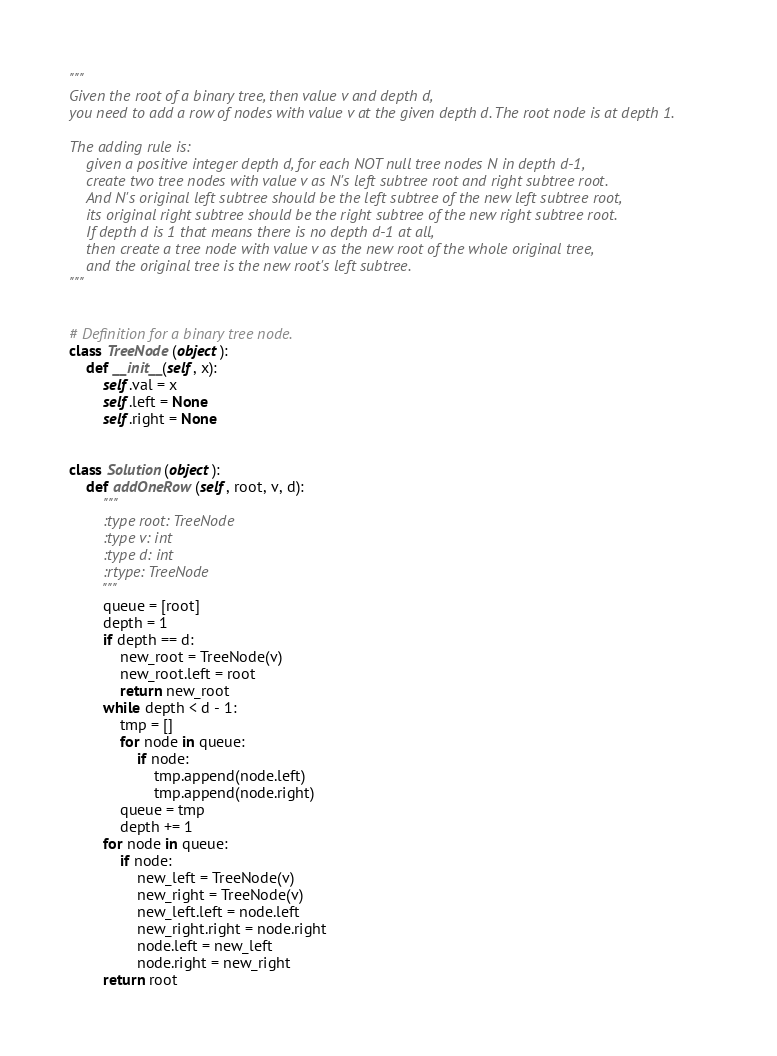Convert code to text. <code><loc_0><loc_0><loc_500><loc_500><_Python_>
"""
Given the root of a binary tree, then value v and depth d, 
you need to add a row of nodes with value v at the given depth d. The root node is at depth 1.

The adding rule is: 
    given a positive integer depth d, for each NOT null tree nodes N in depth d-1, 
    create two tree nodes with value v as N's left subtree root and right subtree root. 
    And N's original left subtree should be the left subtree of the new left subtree root, 
    its original right subtree should be the right subtree of the new right subtree root. 
    If depth d is 1 that means there is no depth d-1 at all, 
    then create a tree node with value v as the new root of the whole original tree, 
    and the original tree is the new root's left subtree.
"""


# Definition for a binary tree node.
class TreeNode(object):
    def __init__(self, x):
        self.val = x
        self.left = None
        self.right = None


class Solution(object):
    def addOneRow(self, root, v, d):
        """
        :type root: TreeNode
        :type v: int
        :type d: int
        :rtype: TreeNode
        """
        queue = [root]
        depth = 1
        if depth == d:
            new_root = TreeNode(v)
            new_root.left = root
            return new_root
        while depth < d - 1:
            tmp = []
            for node in queue:
                if node:
                    tmp.append(node.left)
                    tmp.append(node.right)
            queue = tmp
            depth += 1
        for node in queue:
            if node:
                new_left = TreeNode(v)
                new_right = TreeNode(v)
                new_left.left = node.left
                new_right.right = node.right
                node.left = new_left
                node.right = new_right
        return root
</code> 